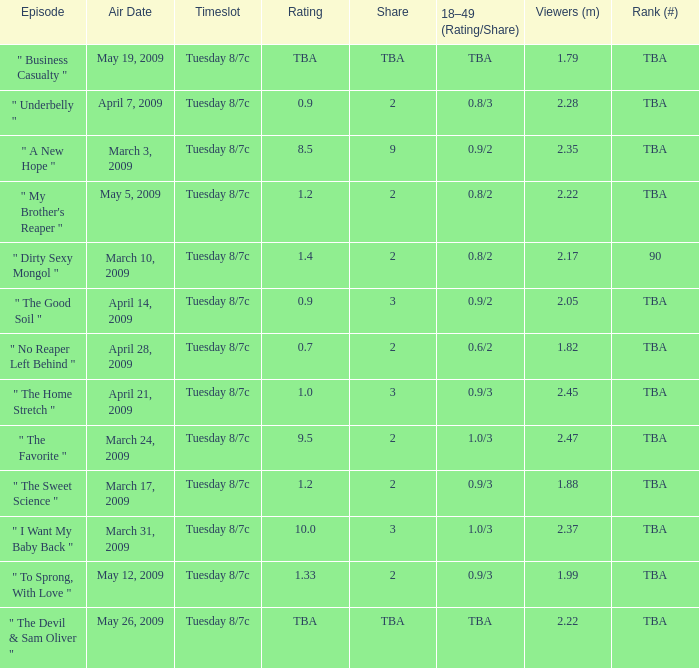What is the rank for the show aired on May 19, 2009? TBA. 